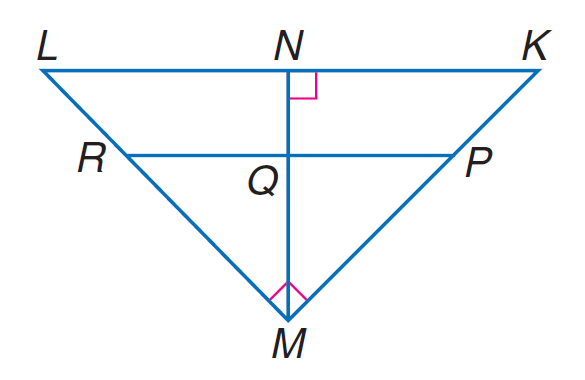Question: If P R \parallel K L, K N = 9, L N = 16, P M = 2 K P, find M L.
Choices:
A. 11
B. 18
C. 20
D. 25
Answer with the letter. Answer: C Question: If P R \parallel K L, K N = 9, L N = 16, P M = 2 K P, find M R.
Choices:
A. 12
B. 26 / 2
C. 40 / 3
D. 14
Answer with the letter. Answer: C Question: If P R \parallel K L, K N = 9, L N = 16, P M = 2 K P, find K P.
Choices:
A. 5
B. 7
C. 8
D. 14
Answer with the letter. Answer: A Question: If P R \parallel K L, K N = 9, L N = 16, P M = 2 K P, find K M.
Choices:
A. 11
B. 15
C. 16.25
D. 17
Answer with the letter. Answer: B 